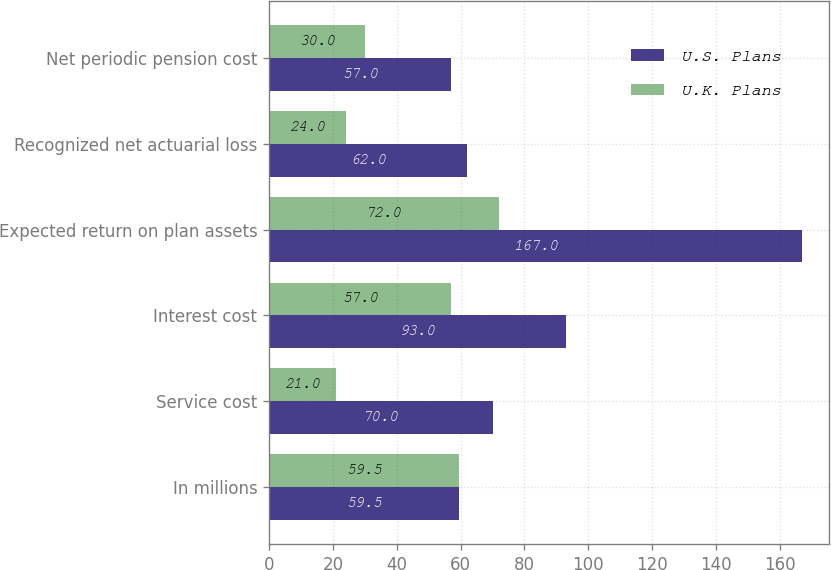Convert chart to OTSL. <chart><loc_0><loc_0><loc_500><loc_500><stacked_bar_chart><ecel><fcel>In millions<fcel>Service cost<fcel>Interest cost<fcel>Expected return on plan assets<fcel>Recognized net actuarial loss<fcel>Net periodic pension cost<nl><fcel>U.S. Plans<fcel>59.5<fcel>70<fcel>93<fcel>167<fcel>62<fcel>57<nl><fcel>U.K. Plans<fcel>59.5<fcel>21<fcel>57<fcel>72<fcel>24<fcel>30<nl></chart> 